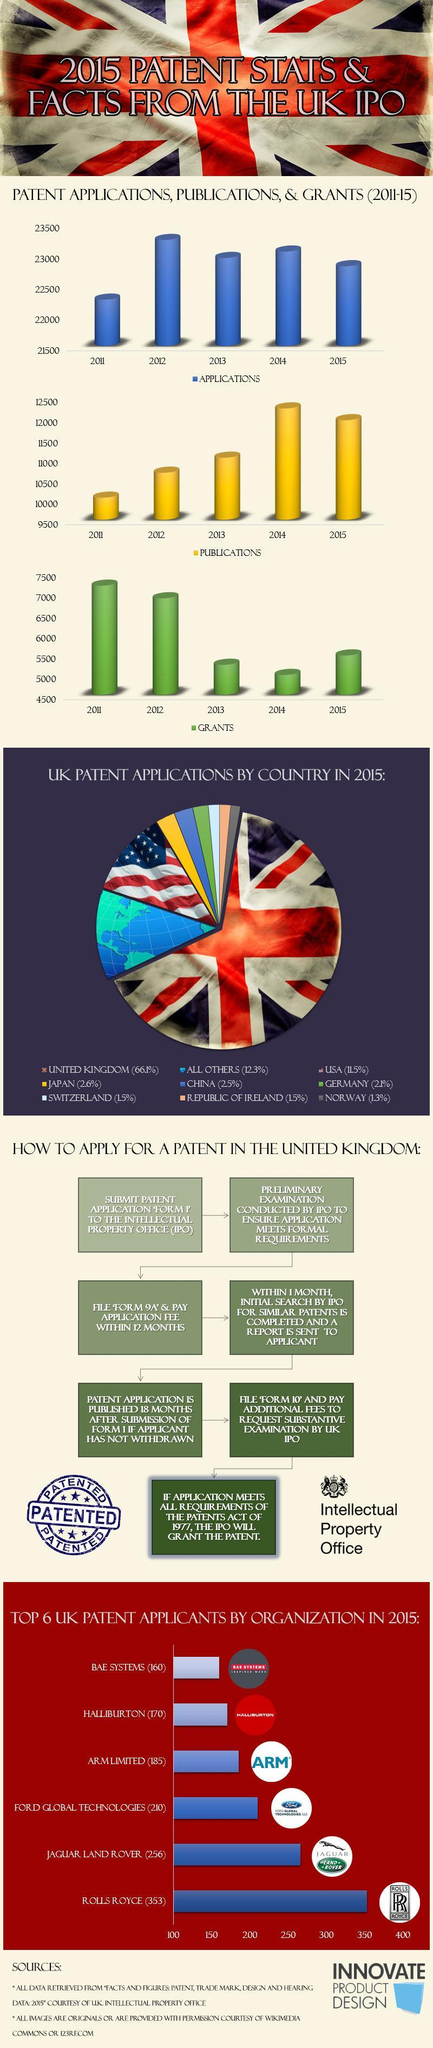What is the third step to apply for a patent in the United Kingdom?
Answer the question with a short phrase. file 'form 9A' & pay application fee within 12 months 